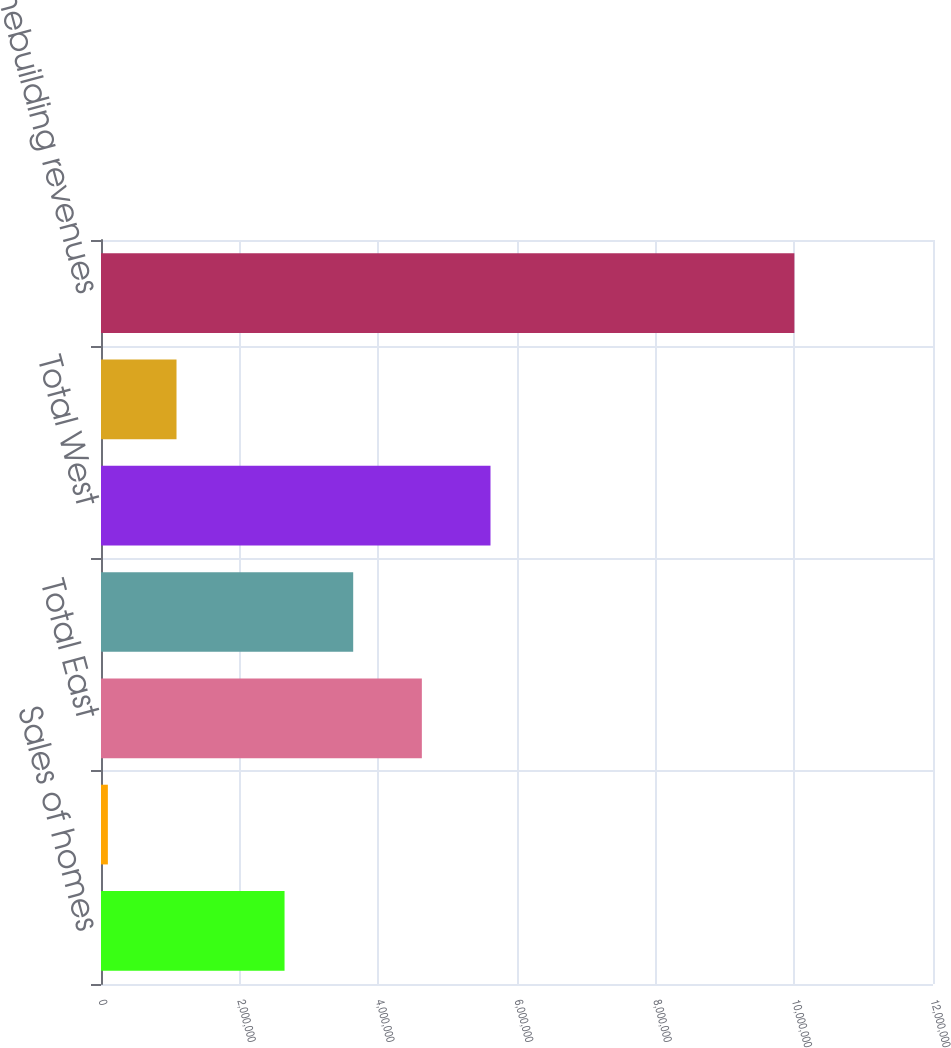Convert chart to OTSL. <chart><loc_0><loc_0><loc_500><loc_500><bar_chart><fcel>Sales of homes<fcel>Sales of land<fcel>Total East<fcel>Total Central<fcel>Total West<fcel>Total Other<fcel>Total homebuilding revenues<nl><fcel>2.64729e+06<fcel>98994<fcel>4.62762e+06<fcel>3.63746e+06<fcel>5.61779e+06<fcel>1.08916e+06<fcel>1.00006e+07<nl></chart> 